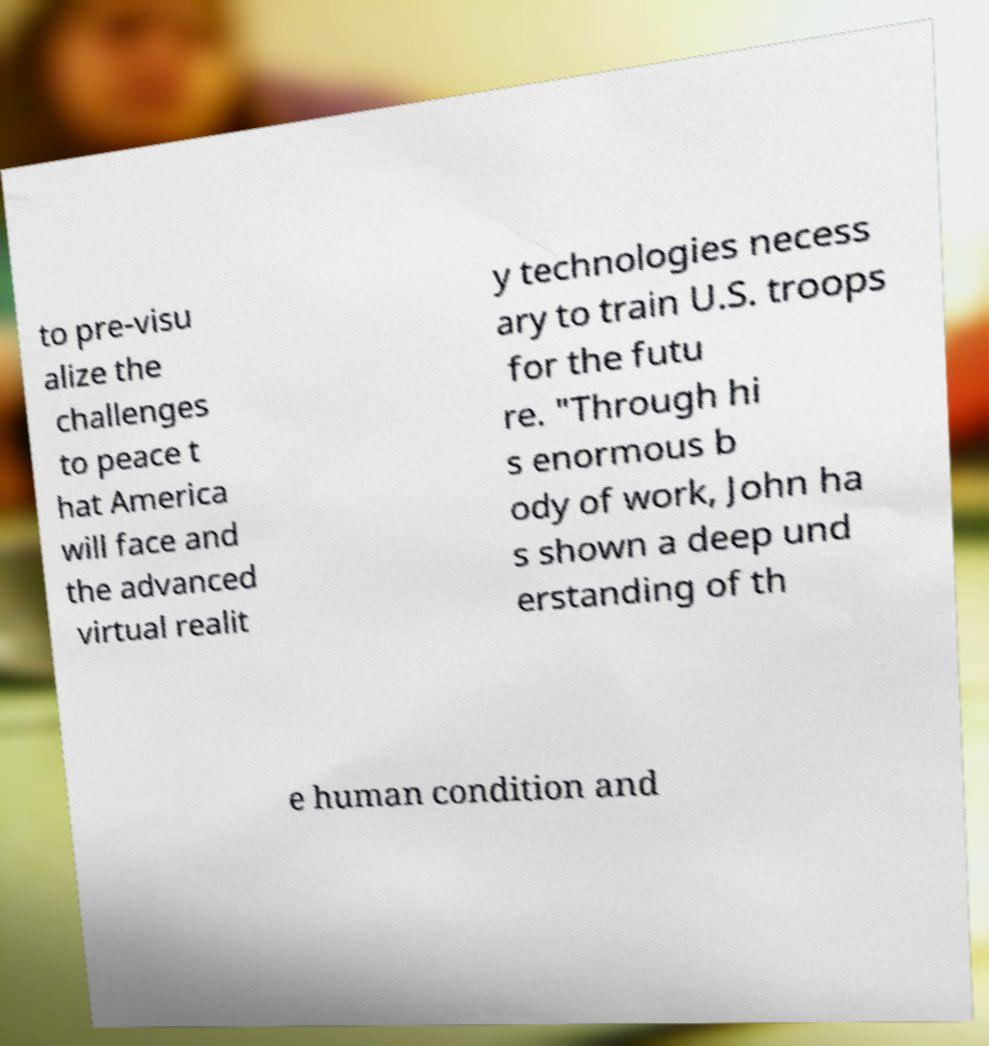Please identify and transcribe the text found in this image. to pre-visu alize the challenges to peace t hat America will face and the advanced virtual realit y technologies necess ary to train U.S. troops for the futu re. "Through hi s enormous b ody of work, John ha s shown a deep und erstanding of th e human condition and 